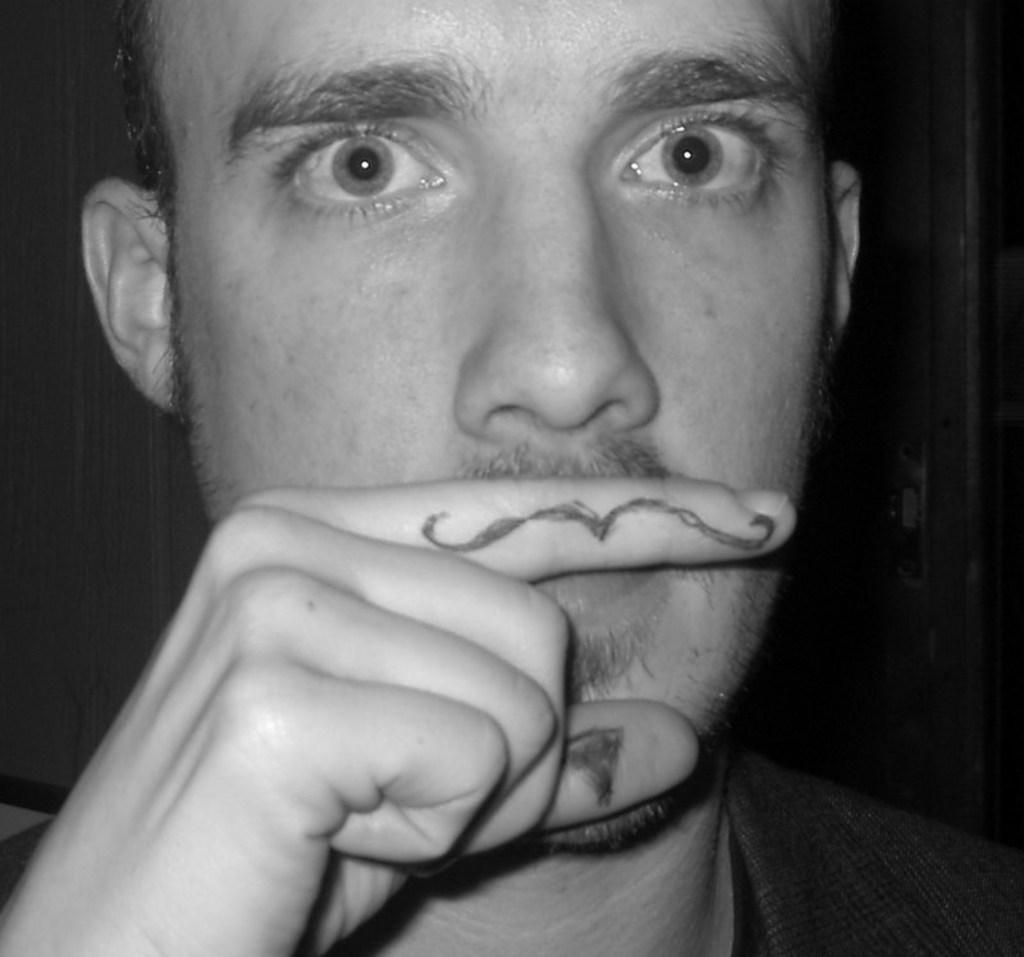What is the color scheme of the image? The image is black and white. Can you describe the main subject of the image? There is a person in the image. What is unique about the person's appearance? The person has art on their fingers. How would you describe the overall lighting in the image? The background of the image is dark. What is the distance between the person and the record in the image? There is no record present in the image, so it is not possible to determine the distance between the person and a record. 